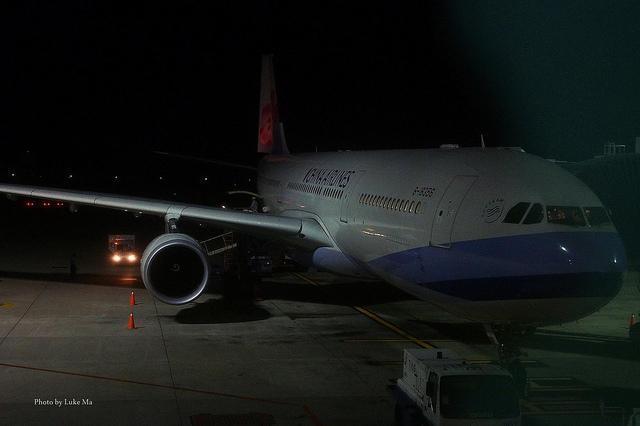How many cones are in the picture?
Give a very brief answer. 2. 